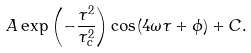<formula> <loc_0><loc_0><loc_500><loc_500>A \exp \left ( { - \frac { \tau ^ { 2 } } { \tau _ { c } ^ { 2 } } } \right ) \cos ( 4 \omega \tau + \phi ) + C .</formula> 